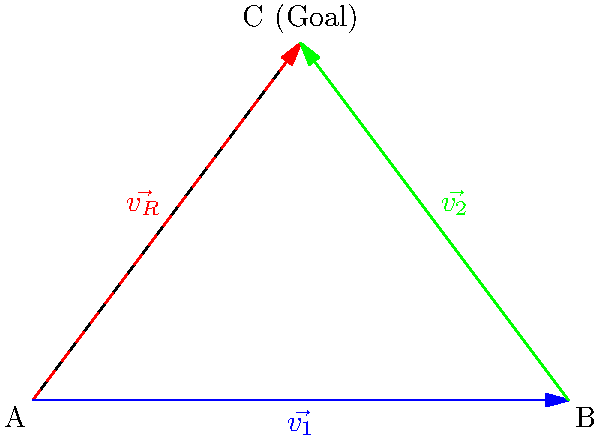In a crucial match for A.S. Cittadella, a player at point A needs to pass the ball to a teammate at point B, who will then kick it towards the goal at point C. If $\vec{v_1}$ represents the vector from A to B, and $\vec{v_2}$ represents the vector from B to C, what is the magnitude of the resultant vector $\vec{v_R}$ that directly connects A to the goal at C? Given that $|\vec{v_1}| = 6$ units and $|\vec{v_2}| = 5$ units. Let's approach this step-by-step:

1) We can use the vector addition property: $\vec{v_R} = \vec{v_1} + \vec{v_2}$

2) We're given the magnitudes of $\vec{v_1}$ and $\vec{v_2}$, but we need to find the angle between them to use the vector addition formula.

3) We can see that $\vec{v_1}$, $\vec{v_2}$, and $\vec{v_R}$ form a triangle. This is a right-angled triangle with $\vec{v_1}$ as the base and $\vec{v_2}$ as the height.

4) We can use the Pythagorean theorem to find $|\vec{v_R}|$:

   $$|\vec{v_R}|^2 = |\vec{v_1}|^2 + |\vec{v_2}|^2$$

5) Substituting the given values:

   $$|\vec{v_R}|^2 = 6^2 + 5^2 = 36 + 25 = 61$$

6) Taking the square root of both sides:

   $$|\vec{v_R}| = \sqrt{61}$$

Therefore, the magnitude of the resultant vector $\vec{v_R}$ is $\sqrt{61}$ units.
Answer: $\sqrt{61}$ units 